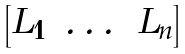Convert formula to latex. <formula><loc_0><loc_0><loc_500><loc_500>\begin{bmatrix} L _ { 1 } & \dots & L _ { n } \end{bmatrix}</formula> 